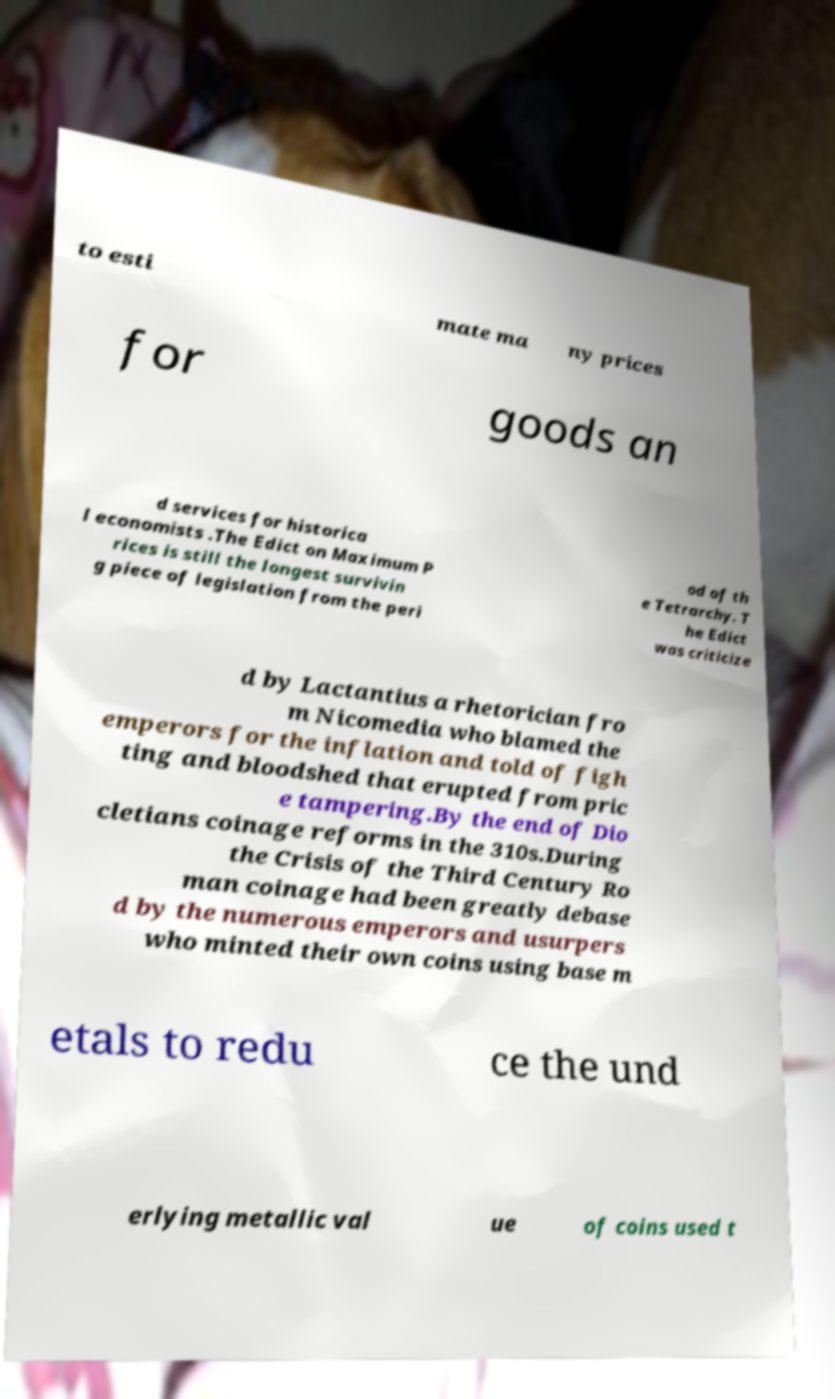Please read and relay the text visible in this image. What does it say? to esti mate ma ny prices for goods an d services for historica l economists .The Edict on Maximum P rices is still the longest survivin g piece of legislation from the peri od of th e Tetrarchy. T he Edict was criticize d by Lactantius a rhetorician fro m Nicomedia who blamed the emperors for the inflation and told of figh ting and bloodshed that erupted from pric e tampering.By the end of Dio cletians coinage reforms in the 310s.During the Crisis of the Third Century Ro man coinage had been greatly debase d by the numerous emperors and usurpers who minted their own coins using base m etals to redu ce the und erlying metallic val ue of coins used t 